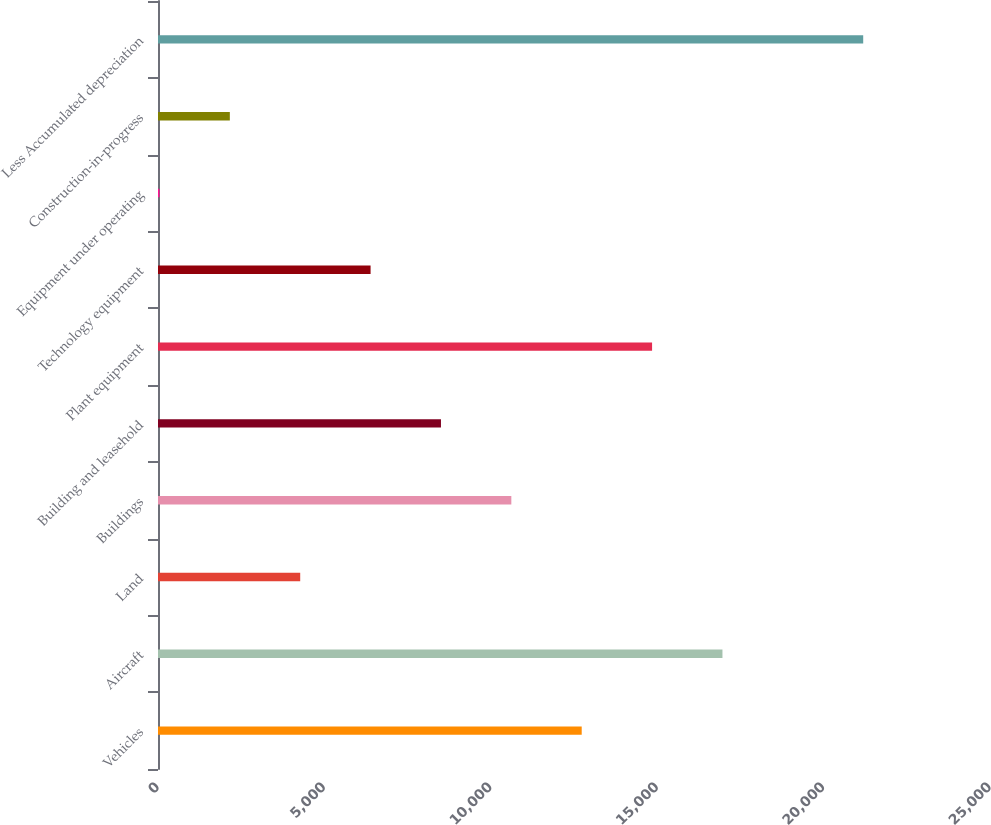Convert chart. <chart><loc_0><loc_0><loc_500><loc_500><bar_chart><fcel>Vehicles<fcel>Aircraft<fcel>Land<fcel>Buildings<fcel>Building and leasehold<fcel>Plant equipment<fcel>Technology equipment<fcel>Equipment under operating<fcel>Construction-in-progress<fcel>Less Accumulated depreciation<nl><fcel>12731.6<fcel>16960.8<fcel>4273.2<fcel>10617<fcel>8502.4<fcel>14846.2<fcel>6387.8<fcel>44<fcel>2158.6<fcel>21190<nl></chart> 